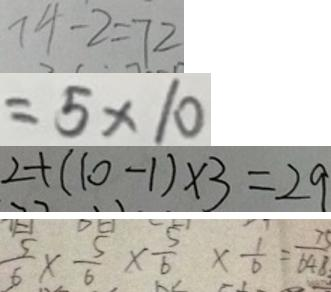<formula> <loc_0><loc_0><loc_500><loc_500>7 4 - 2 = 7 2 
 = 5 \times 1 0 
 2 + ( 1 0 - 1 ) \times 3 = 2 9 
 \frac { 5 } { 6 } \times \frac { 5 } { 6 } \times \frac { 5 } { 6 } \times \frac { 1 } { 6 } = \frac { 7 5 } { 6 4 8 }</formula> 